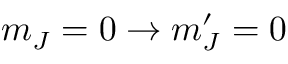<formula> <loc_0><loc_0><loc_500><loc_500>m _ { J } = 0 \to m _ { J } ^ { \prime } = 0</formula> 